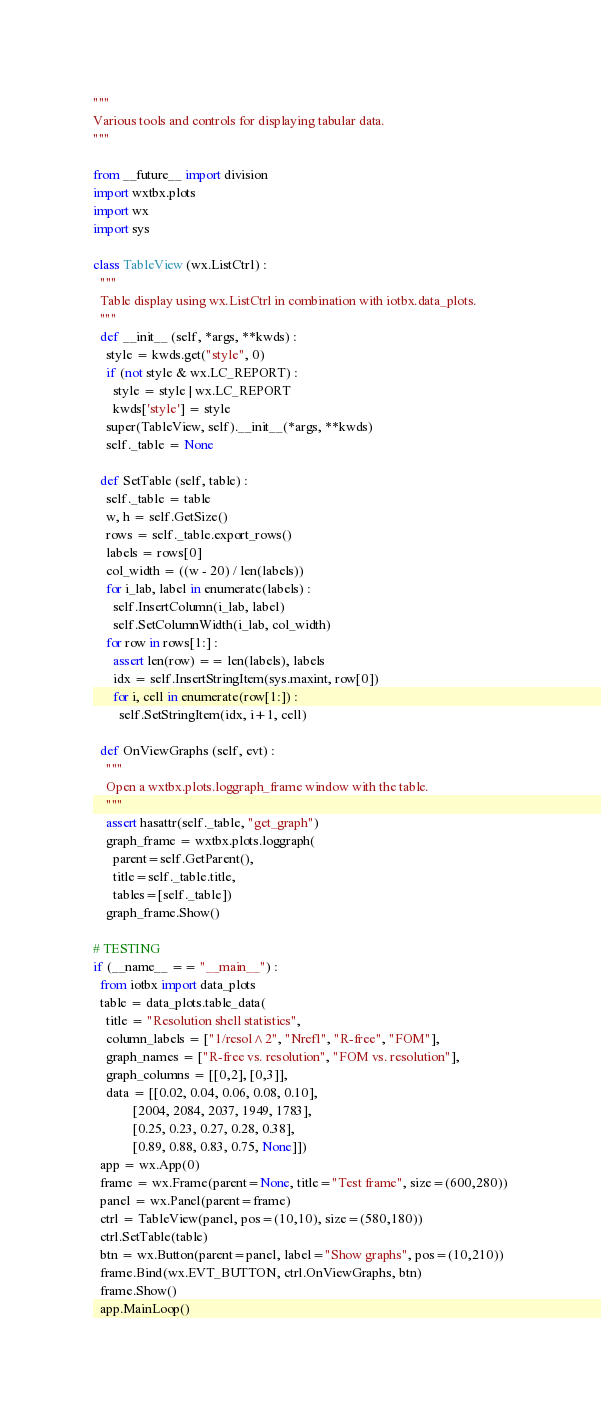<code> <loc_0><loc_0><loc_500><loc_500><_Python_>
"""
Various tools and controls for displaying tabular data.
"""

from __future__ import division
import wxtbx.plots
import wx
import sys

class TableView (wx.ListCtrl) :
  """
  Table display using wx.ListCtrl in combination with iotbx.data_plots.
  """
  def __init__ (self, *args, **kwds) :
    style = kwds.get("style", 0)
    if (not style & wx.LC_REPORT) :
      style = style | wx.LC_REPORT
      kwds['style'] = style
    super(TableView, self).__init__(*args, **kwds)
    self._table = None

  def SetTable (self, table) :
    self._table = table
    w, h = self.GetSize()
    rows = self._table.export_rows()
    labels = rows[0]
    col_width = ((w - 20) / len(labels))
    for i_lab, label in enumerate(labels) :
      self.InsertColumn(i_lab, label)
      self.SetColumnWidth(i_lab, col_width)
    for row in rows[1:] :
      assert len(row) == len(labels), labels
      idx = self.InsertStringItem(sys.maxint, row[0])
      for i, cell in enumerate(row[1:]) :
        self.SetStringItem(idx, i+1, cell)

  def OnViewGraphs (self, evt) :
    """
    Open a wxtbx.plots.loggraph_frame window with the table.
    """
    assert hasattr(self._table, "get_graph")
    graph_frame = wxtbx.plots.loggraph(
      parent=self.GetParent(),
      title=self._table.title,
      tables=[self._table])
    graph_frame.Show()

# TESTING
if (__name__ == "__main__") :
  from iotbx import data_plots
  table = data_plots.table_data(
    title = "Resolution shell statistics",
    column_labels = ["1/resol^2", "Nrefl", "R-free", "FOM"],
    graph_names = ["R-free vs. resolution", "FOM vs. resolution"],
    graph_columns = [[0,2], [0,3]],
    data = [[0.02, 0.04, 0.06, 0.08, 0.10],
            [2004, 2084, 2037, 1949, 1783],
            [0.25, 0.23, 0.27, 0.28, 0.38],
            [0.89, 0.88, 0.83, 0.75, None]])
  app = wx.App(0)
  frame = wx.Frame(parent=None, title="Test frame", size=(600,280))
  panel = wx.Panel(parent=frame)
  ctrl = TableView(panel, pos=(10,10), size=(580,180))
  ctrl.SetTable(table)
  btn = wx.Button(parent=panel, label="Show graphs", pos=(10,210))
  frame.Bind(wx.EVT_BUTTON, ctrl.OnViewGraphs, btn)
  frame.Show()
  app.MainLoop()
</code> 